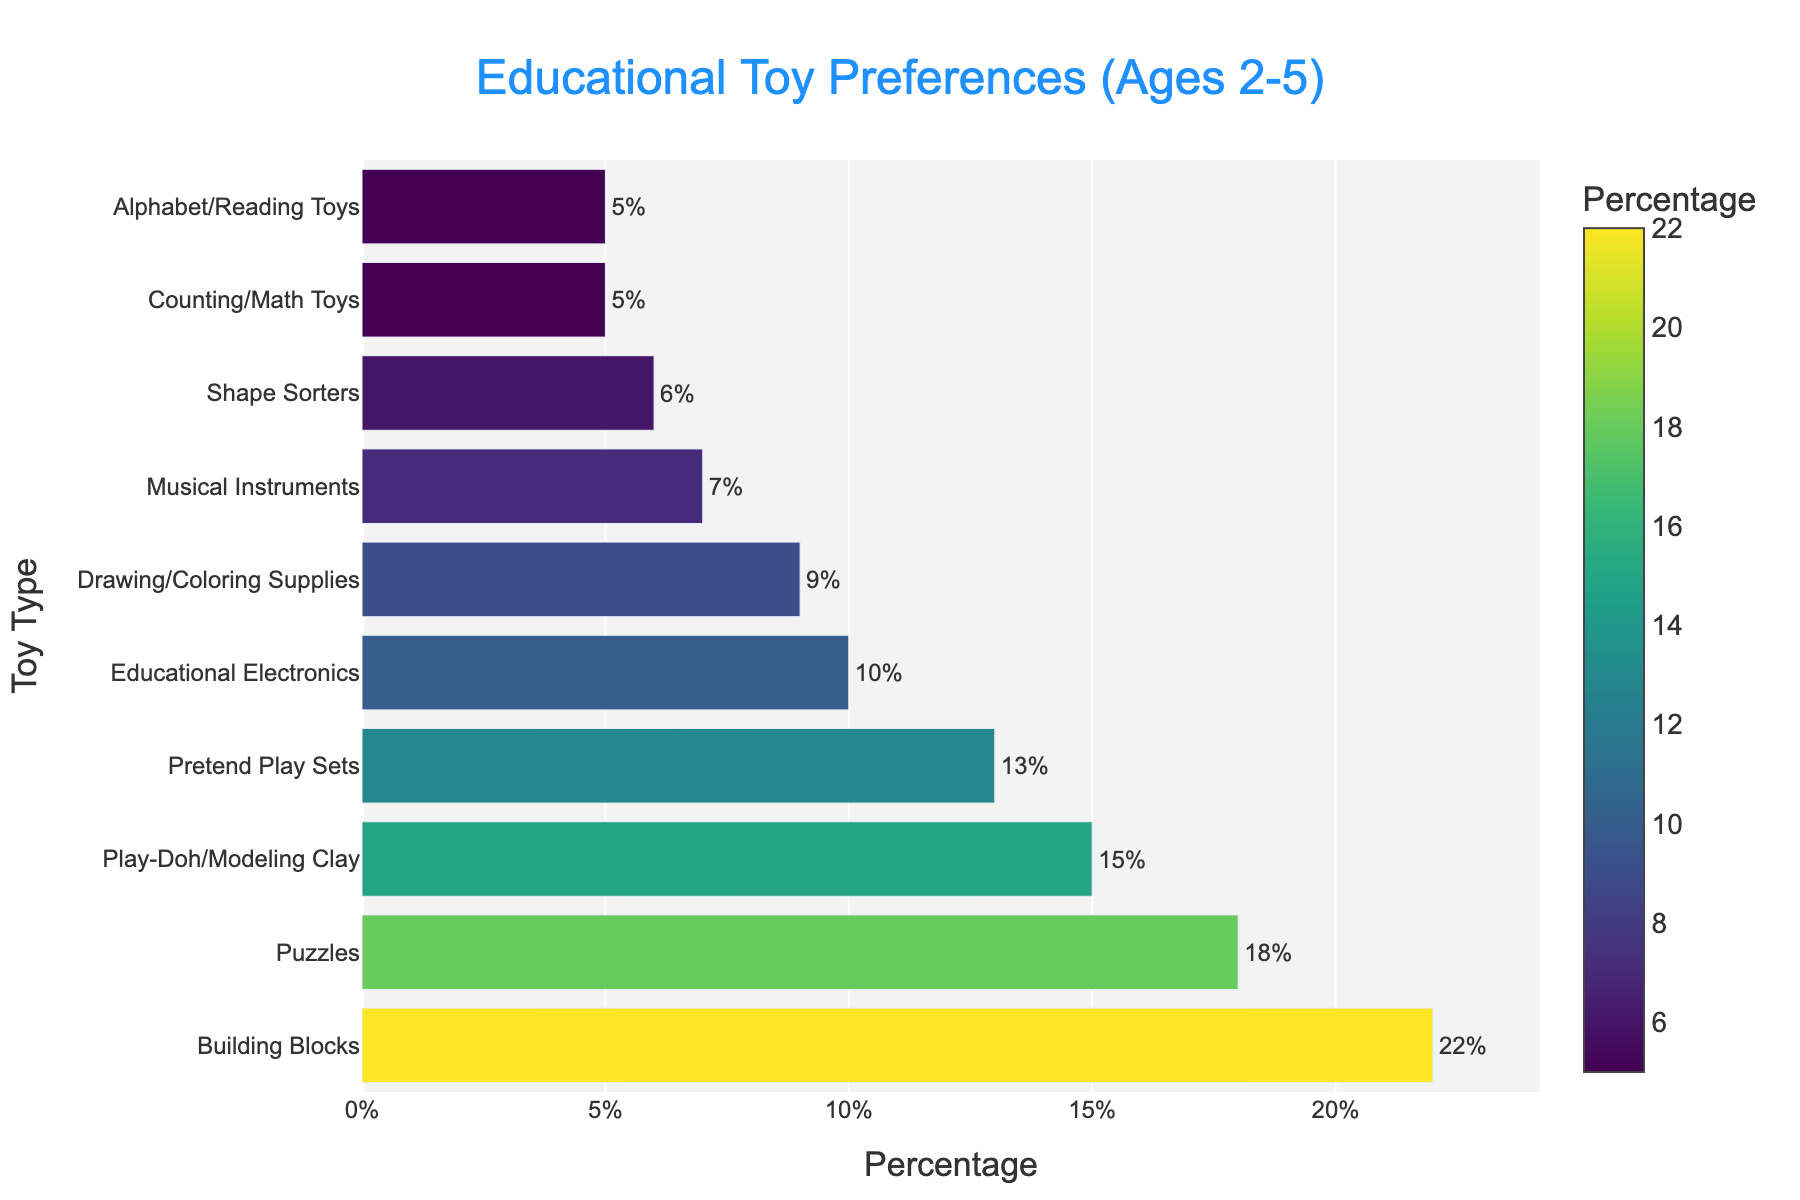What is the most preferred educational toy among children aged 2-5? The bar chart shows the breakdown of educational toy preferences. The toy with the highest percentage is the most preferred.
Answer: Building Blocks What is the total percentage of children who prefer Play-Doh/Modeling Clay and Pretend Play Sets? Add the percentage values for Play-Doh/Modeling Clay (15%) and Pretend Play Sets (13%).
Answer: 28% Which toy type is preferred less: Shape Sorters or Counting/Math Toys? Compare the percentages of Shape Sorters (6%) and Counting/Math Toys (5%). The one with the lower percentage is less preferred.
Answer: Counting/Math Toys How much more popular are Building Blocks compared to Alphabet/Reading Toys? Subtract the percentage of Alphabet/Reading Toys (5%) from the percentage of Building Blocks (22%).
Answer: 17% Are more children interested in Educational Electronics than in Musical Instruments? Compare the percentages of Educational Electronics (10%) and Musical Instruments (7%).
Answer: Yes Which toy type has the third-highest preference? Identify the toy with the third-highest bar in the chart. The first is Building Blocks, the second is Puzzles, and the third is Play-Doh/Modeling Clay.
Answer: Play-Doh/Modeling Clay What percentage of children prefer Drawing/Coloring Supplies? Identify the percentage associated with Drawing/Coloring Supplies from the chart.
Answer: 9% Which two toys have the same percentage of preference? Identify the bars with the same percentage. Both Counting/Math Toys and Alphabet/Reading Toys have 5%.
Answer: Counting/Math Toys and Alphabet/Reading Toys How much less popular are Puzzles compared to Building Blocks? Subtract the percentage of Puzzles (18%) from the percentage of Building Blocks (22%).
Answer: 4% What is the average percentage preference for the top three toys? Sum the percentages of the top three toys: Building Blocks (22%), Puzzles (18%), Play-Doh/Modeling Clay (15%). Divide by 3. (22 + 18 + 15) / 3
Answer: 18.33% 